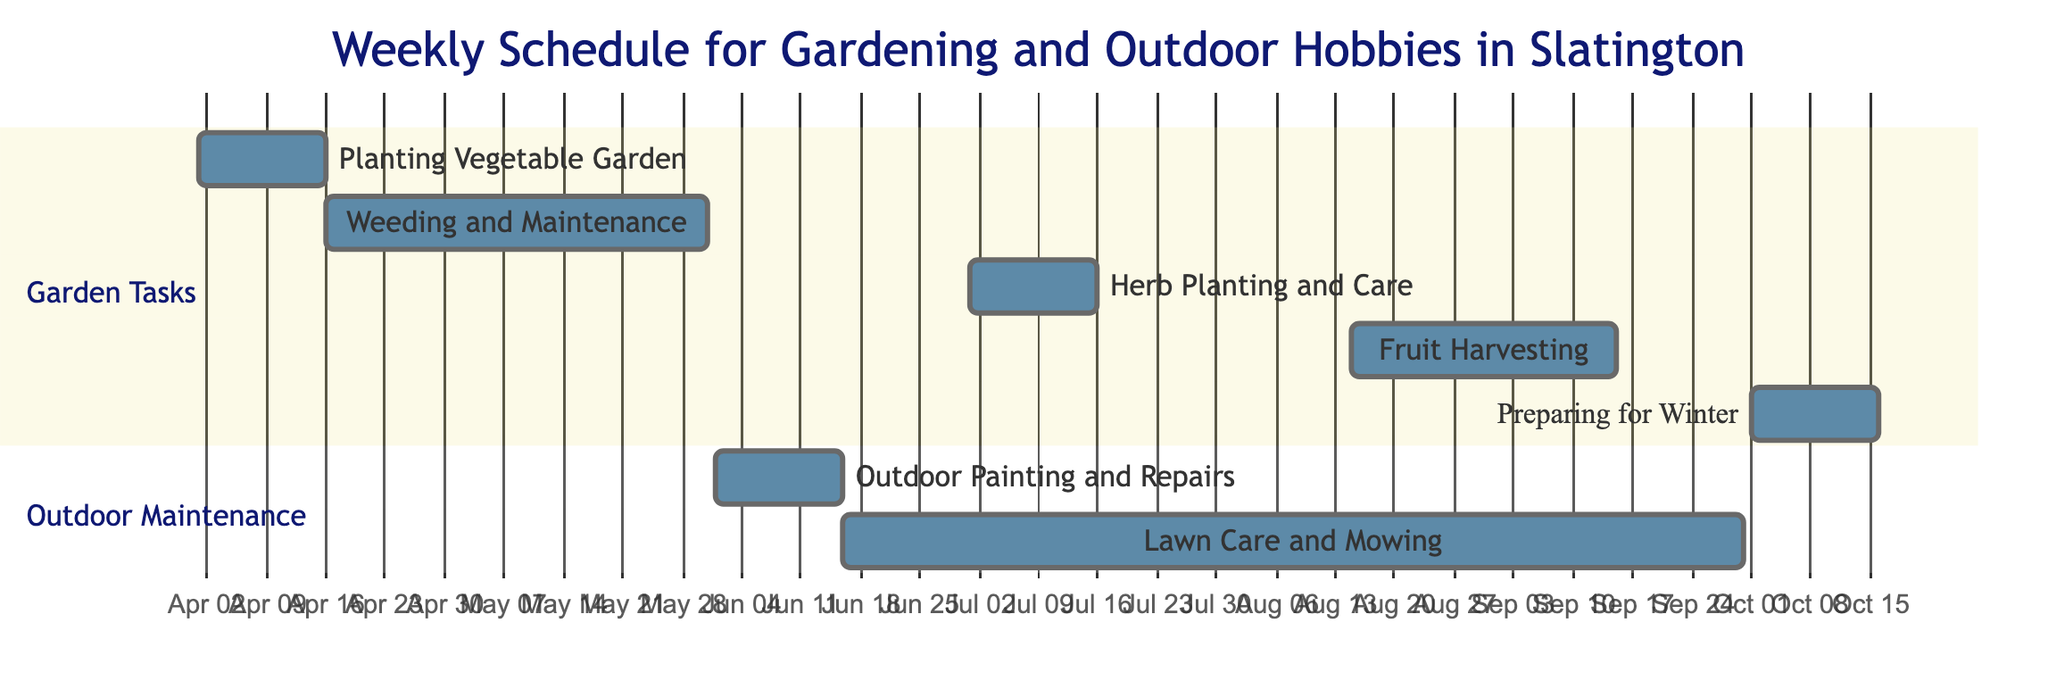How many tasks are in the diagram? The diagram contains seven tasks spread across two sections: "Garden Tasks" and "Outdoor Maintenance." Counting each task listed in these sections gives us a total of 7.
Answer: 7 What is the duration of "Weeding and Maintenance"? The "Weeding and Maintenance" task is listed in the diagram with a duration of 45 days, which is directly specified next to the task name.
Answer: 45 days Which task starts on June 1? The task that starts on June 1 is "Outdoor Painting and Repairs," as it is the only task in the diagram with that specific start date identified.
Answer: Outdoor Painting and Repairs What task overlaps with "Lawn Care and Mowing"? The "Weeding and Maintenance" task overlaps with "Lawn Care and Mowing" because it ends on May 31 and the latter starts on June 16, indicating a continuity in gardening activities.
Answer: Weeding and Maintenance When does "Preparing for Winter" begin? The task "Preparing for Winter" begins on October 1, as indicated by the start date listed beside the task in the Gantt chart.
Answer: October 1 How many days does "Herb Planting and Care" last? "Herb Planting and Care" lasts for 15 days, as this duration is clearly stated next to the task in the diagram.
Answer: 15 days Which task has the longest duration? The task with the longest duration in the diagram is "Lawn Care and Mowing," which lasts for 106 days, as specified in the duration section for this task.
Answer: 106 days What is the end date of "Fruit Harvesting"? The end date for "Fruit Harvesting" is September 15, according to the information provided in the Gantt chart next to this task.
Answer: September 15 What section includes "Herb Planting and Care"? The "Herb Planting and Care" task is included in the "Garden Tasks" section, as all gardening-related tasks are grouped there in the chart.
Answer: Garden Tasks 